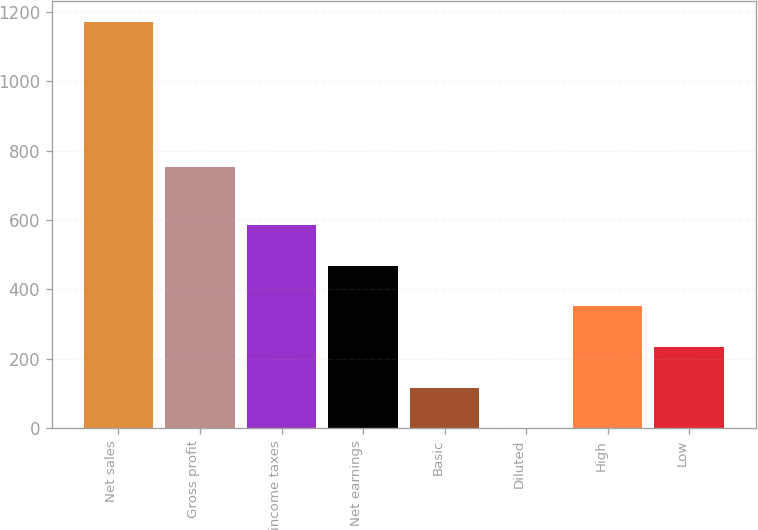<chart> <loc_0><loc_0><loc_500><loc_500><bar_chart><fcel>Net sales<fcel>Gross profit<fcel>income taxes<fcel>Net earnings<fcel>Basic<fcel>Diluted<fcel>High<fcel>Low<nl><fcel>1171.9<fcel>754.6<fcel>586.09<fcel>468.93<fcel>117.45<fcel>0.29<fcel>351.77<fcel>234.61<nl></chart> 